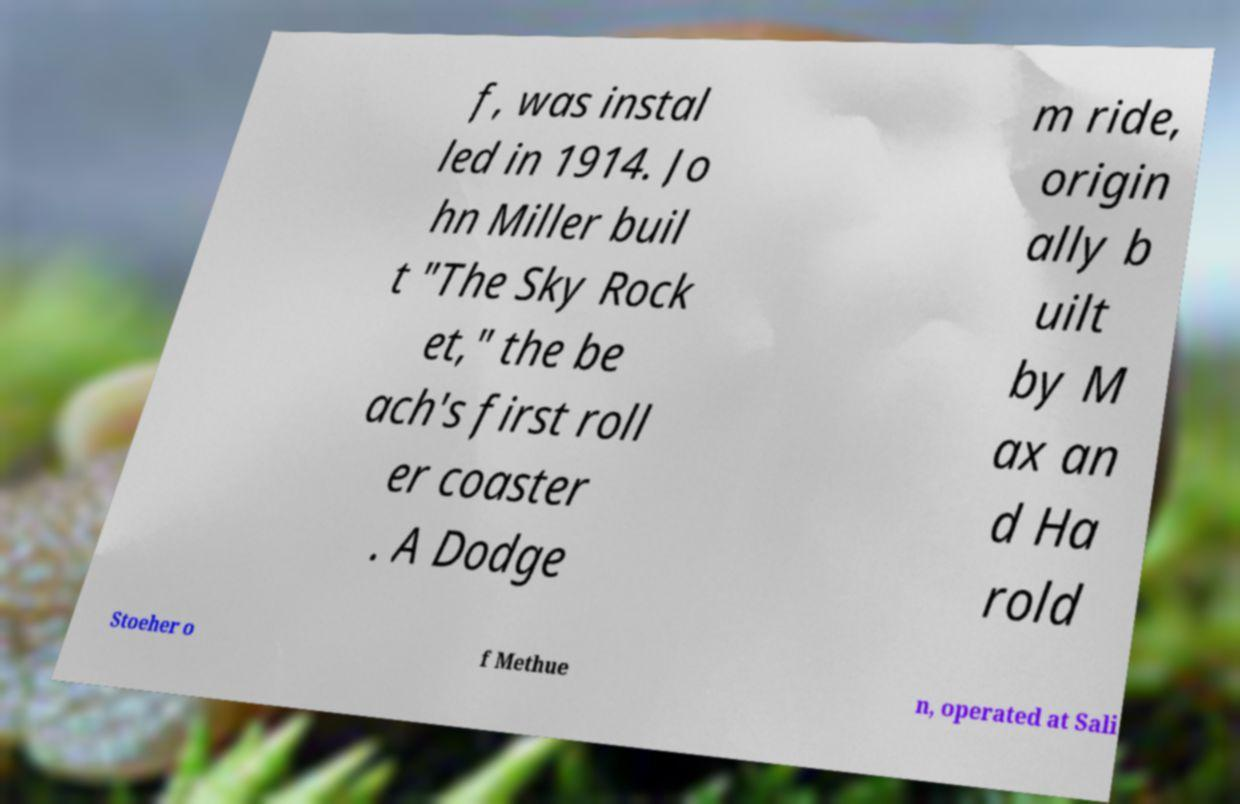I need the written content from this picture converted into text. Can you do that? f, was instal led in 1914. Jo hn Miller buil t "The Sky Rock et," the be ach's first roll er coaster . A Dodge m ride, origin ally b uilt by M ax an d Ha rold Stoeher o f Methue n, operated at Sali 